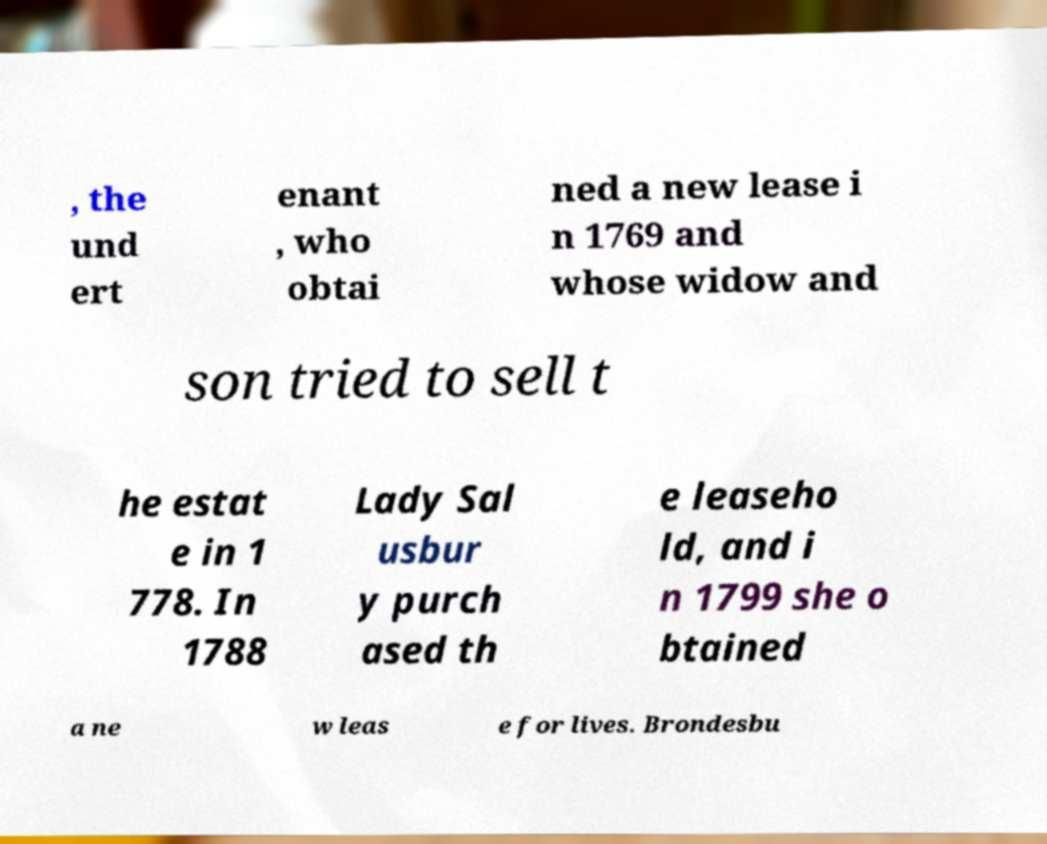What messages or text are displayed in this image? I need them in a readable, typed format. , the und ert enant , who obtai ned a new lease i n 1769 and whose widow and son tried to sell t he estat e in 1 778. In 1788 Lady Sal usbur y purch ased th e leaseho ld, and i n 1799 she o btained a ne w leas e for lives. Brondesbu 